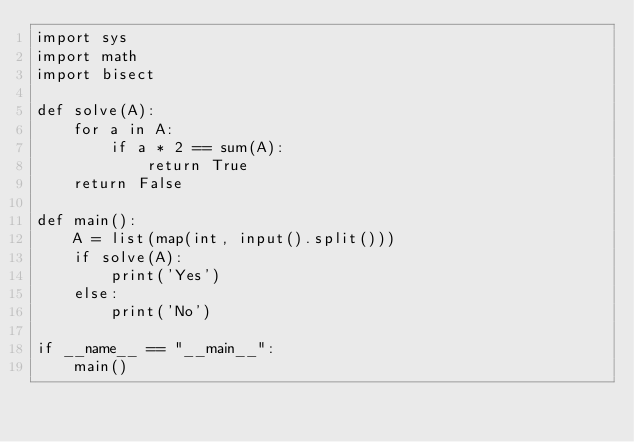<code> <loc_0><loc_0><loc_500><loc_500><_Python_>import sys
import math
import bisect

def solve(A):
    for a in A:
        if a * 2 == sum(A):
            return True
    return False
 
def main():
    A = list(map(int, input().split()))
    if solve(A):
        print('Yes')
    else:
        print('No')
 
if __name__ == "__main__":
    main()
</code> 